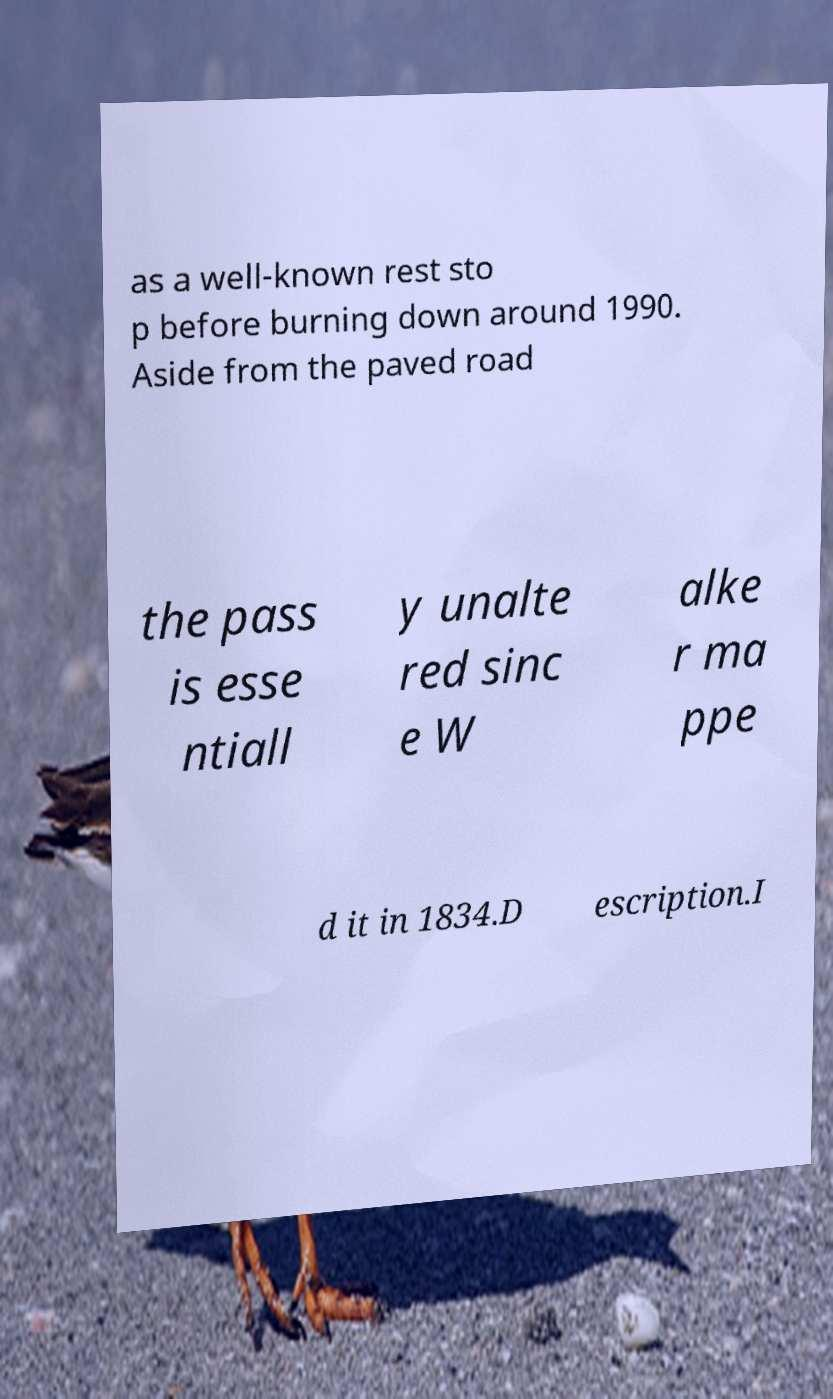Please identify and transcribe the text found in this image. as a well-known rest sto p before burning down around 1990. Aside from the paved road the pass is esse ntiall y unalte red sinc e W alke r ma ppe d it in 1834.D escription.I 